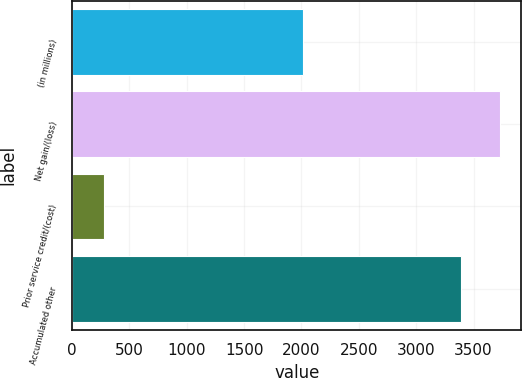Convert chart. <chart><loc_0><loc_0><loc_500><loc_500><bar_chart><fcel>(in millions)<fcel>Net gain/(loss)<fcel>Prior service credit/(cost)<fcel>Accumulated other<nl><fcel>2011<fcel>3730.1<fcel>278<fcel>3391<nl></chart> 